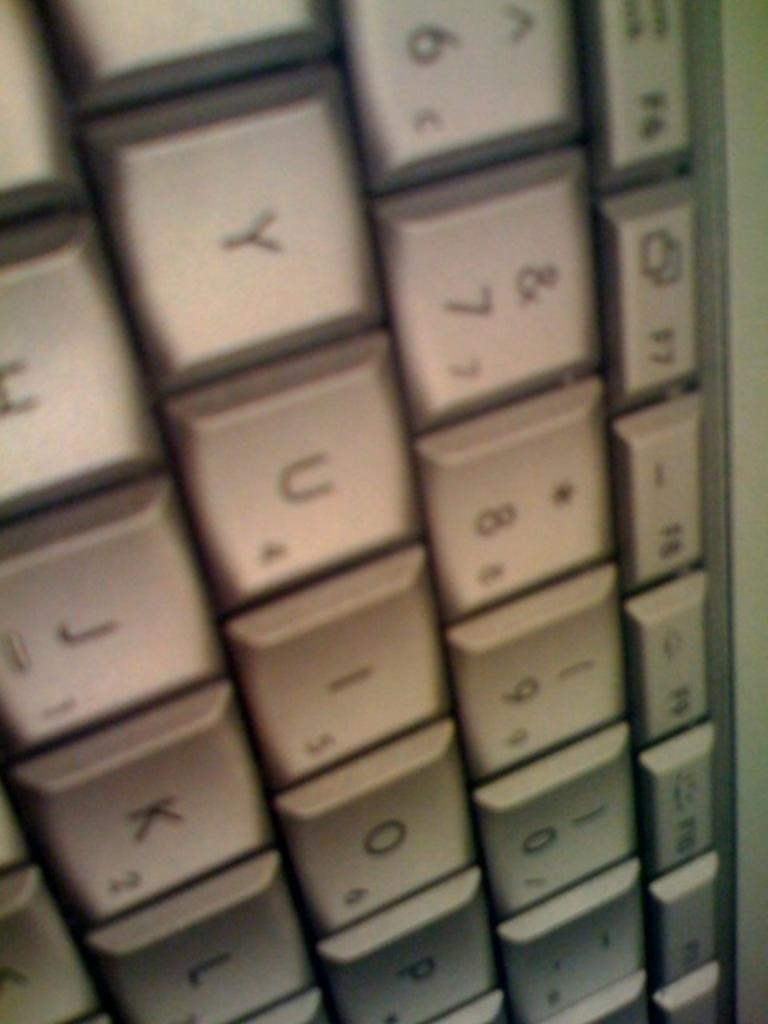<image>
Give a short and clear explanation of the subsequent image. A computer keyboard has the U letter next to the Y key. 